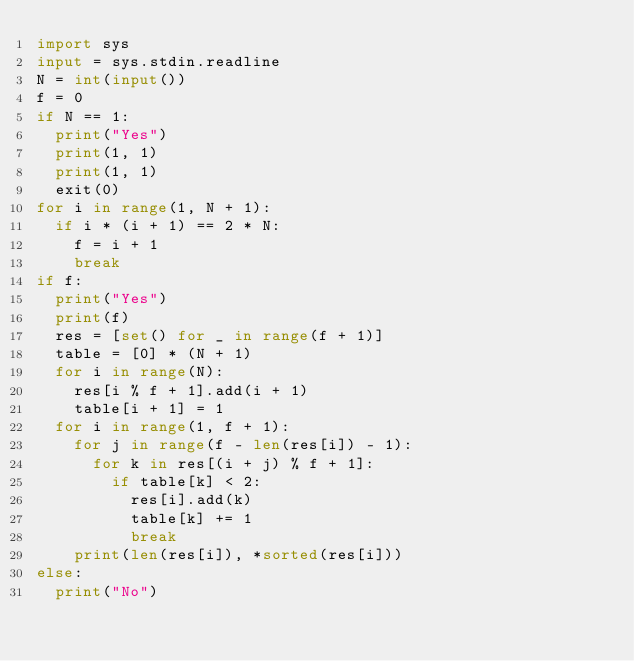Convert code to text. <code><loc_0><loc_0><loc_500><loc_500><_Python_>import sys
input = sys.stdin.readline
N = int(input())
f = 0
if N == 1:
  print("Yes")
  print(1, 1)
  print(1, 1)
  exit(0)
for i in range(1, N + 1):
  if i * (i + 1) == 2 * N:
    f = i + 1
    break
if f:
  print("Yes")
  print(f)
  res = [set() for _ in range(f + 1)]
  table = [0] * (N + 1)
  for i in range(N):
    res[i % f + 1].add(i + 1)
    table[i + 1] = 1
  for i in range(1, f + 1):
    for j in range(f - len(res[i]) - 1):
      for k in res[(i + j) % f + 1]:
        if table[k] < 2:
          res[i].add(k)
          table[k] += 1
          break
    print(len(res[i]), *sorted(res[i]))
else:
  print("No")
</code> 